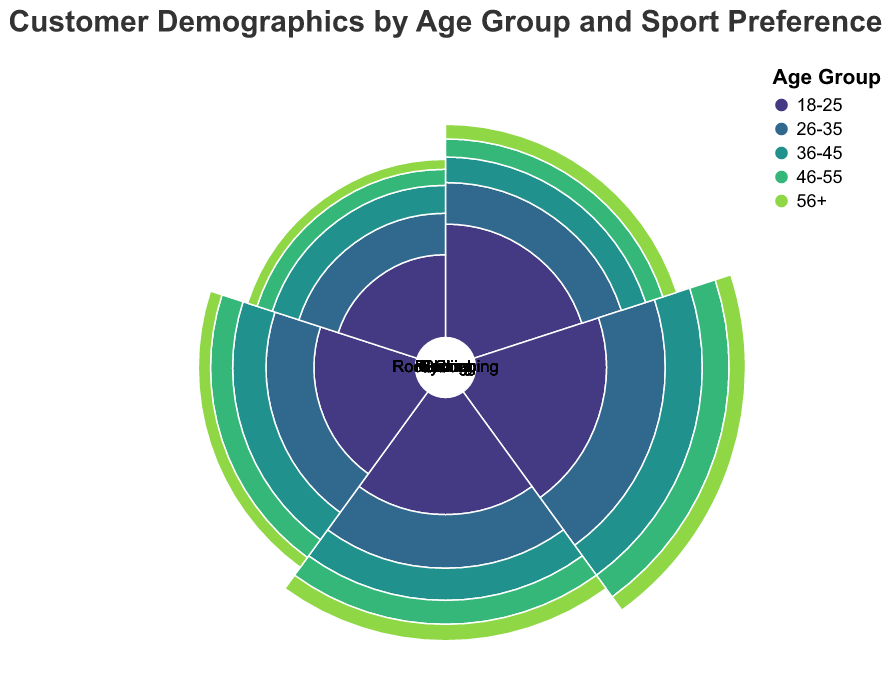What is the most preferred sport for the 18-25 age group? Examine the segments for the 18-25 age group and check the values for each sport. The highest value is found in the segment for Running with a value of 200.
Answer: Running How does the preference for Soccer change across different age groups? Compare the values for Soccer across all age groups: 150 for 18-25, 130 for 26-35, 100 for 36-45, 80 for 46-55, and 70 for 56+. The preference decreases as age increases.
Answer: Decreases Which age group has the highest number of people interested in Rock Climbing? Find the value of Rock Climbing for each age group. The highest value is 100 for the 26-35 age group.
Answer: 26-35 What is the combined total preference for Skiing for the age groups 36-45 and 46-55? Add the values for Skiing in age groups 36-45 and 46-55: 130 + 100 = 230.
Answer: 230 Compare the popularity of Cycling among 26-35-year-olds and 36-45-year-olds. Check the values for Cycling for the 26-35 age group (180) and the 36-45 age group (140). The 26-35 group has a higher preference at 180 compared to 140.
Answer: 26-35 more popular Which sport shows the least variation in preference across all age groups? Calculate the range (maximum value - minimum value) for each sport: Soccer (150-70=80), Running (220-100=120), Cycling (180-90=90), Skiing (140-60=80), Rock Climbing (100-40=60). Rock Climbing has the least variation.
Answer: Rock Climbing What is the average preference for Running across all age groups? Sum the values for Running in all age groups: 200 + 220 + 180 + 150 + 100 = 850. Divide by the number of age groups (5): 850 / 5 = 170.
Answer: 170 